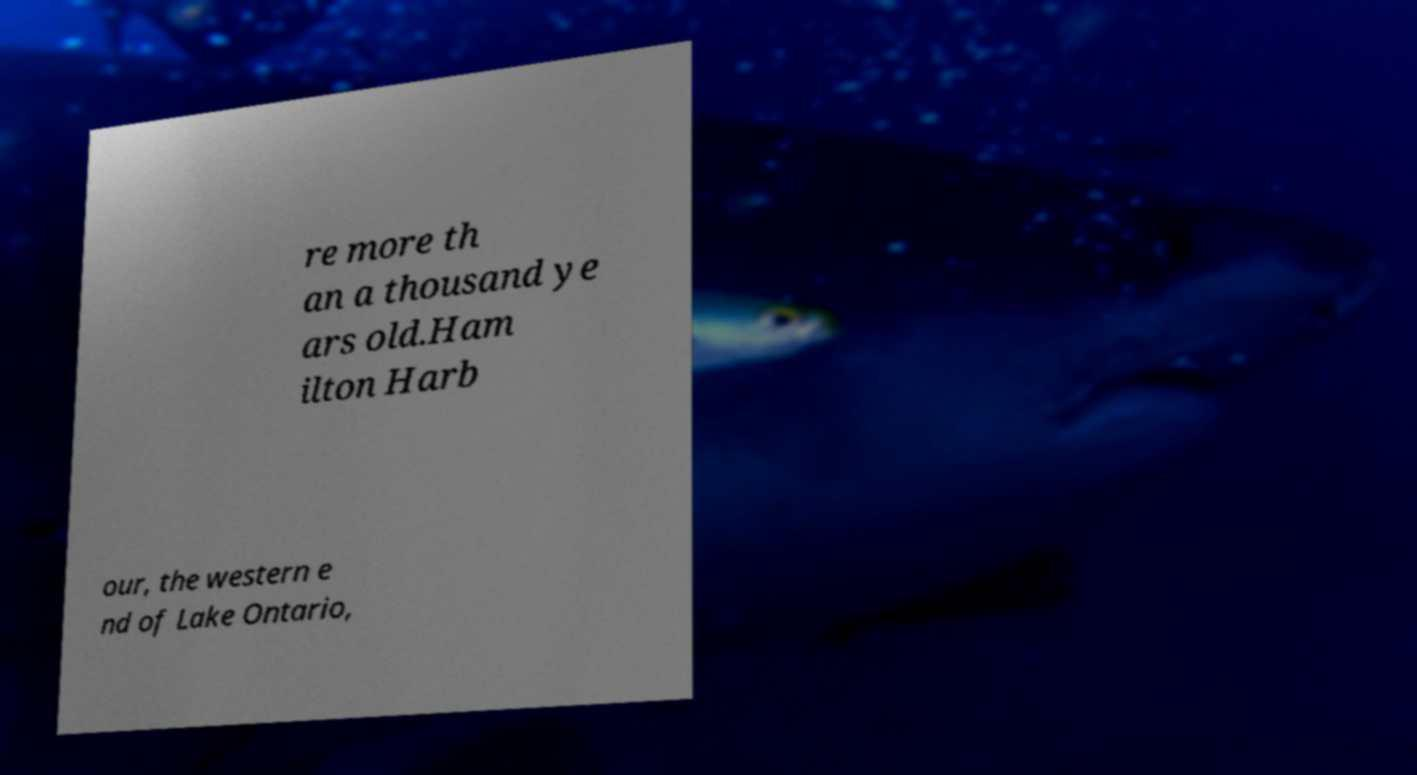There's text embedded in this image that I need extracted. Can you transcribe it verbatim? re more th an a thousand ye ars old.Ham ilton Harb our, the western e nd of Lake Ontario, 